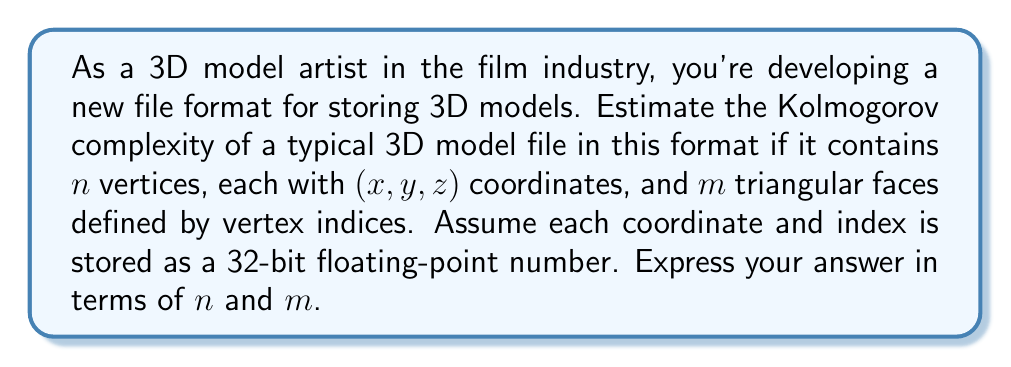Teach me how to tackle this problem. To estimate the Kolmogorov complexity of the 3D model file format, we need to consider the minimum amount of information required to represent the model. Let's break this down step-by-step:

1. Vertex information:
   - Each vertex has 3 coordinates $(x,y,z)$
   - Each coordinate is stored as a 32-bit floating-point number
   - Total bits for vertices: $n \times 3 \times 32 = 96n$ bits

2. Face information:
   - Each triangular face is defined by 3 vertex indices
   - Each index is stored as a 32-bit floating-point number
   - Total bits for faces: $m \times 3 \times 32 = 96m$ bits

3. File structure overhead:
   - We need to account for some minimal overhead to define the file structure
   - This might include headers, separators, or metadata
   - Let's estimate this as a constant $c$ bits

The total number of bits required to represent the 3D model would be:

$$ \text{Total bits} = 96n + 96m + c $$

The Kolmogorov complexity is defined as the length of the shortest program that can produce the given output. In this case, we can consider a program that simply lists all the vertex coordinates and face indices. The complexity of this program would be proportional to the number of bits required to store this information.

Therefore, we can estimate the Kolmogorov complexity as:

$$ K(file) \approx O(96n + 96m + c) $$

Simplifying and dropping the constant term for asymptotic notation:

$$ K(file) = O(n + m) $$

This estimate assumes that there is no significant compression or more efficient representation possible for the given 3D model. In practice, there might be ways to reduce this complexity through various compression techniques or by exploiting patterns in the model structure.
Answer: $K(file) = O(n + m)$, where $n$ is the number of vertices and $m$ is the number of faces in the 3D model. 